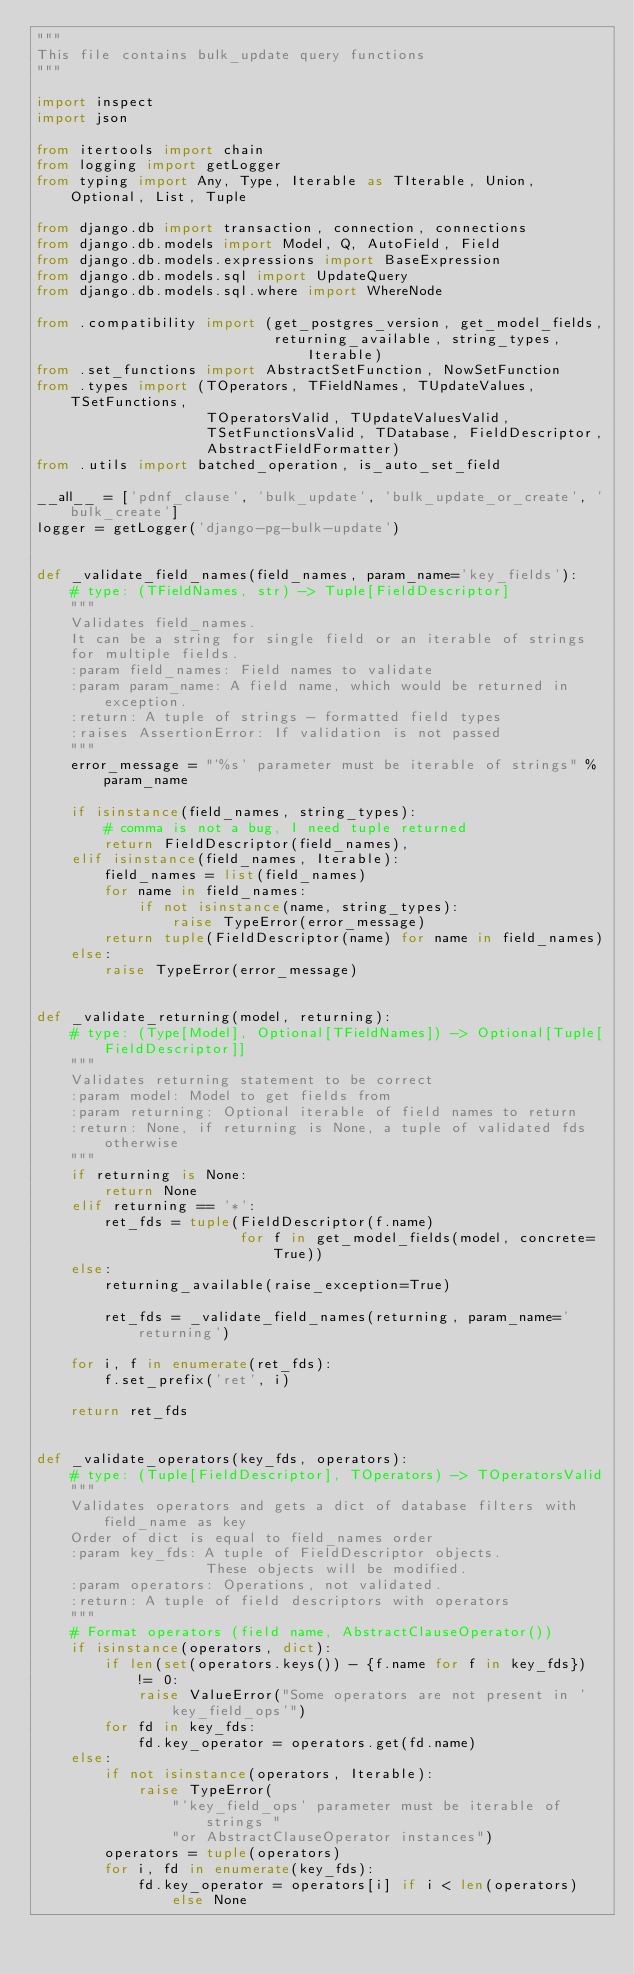Convert code to text. <code><loc_0><loc_0><loc_500><loc_500><_Python_>"""
This file contains bulk_update query functions
"""

import inspect
import json

from itertools import chain
from logging import getLogger
from typing import Any, Type, Iterable as TIterable, Union, Optional, List, Tuple

from django.db import transaction, connection, connections
from django.db.models import Model, Q, AutoField, Field
from django.db.models.expressions import BaseExpression
from django.db.models.sql import UpdateQuery
from django.db.models.sql.where import WhereNode

from .compatibility import (get_postgres_version, get_model_fields,
                            returning_available, string_types, Iterable)
from .set_functions import AbstractSetFunction, NowSetFunction
from .types import (TOperators, TFieldNames, TUpdateValues, TSetFunctions,
                    TOperatorsValid, TUpdateValuesValid,
                    TSetFunctionsValid, TDatabase, FieldDescriptor,
                    AbstractFieldFormatter)
from .utils import batched_operation, is_auto_set_field

__all__ = ['pdnf_clause', 'bulk_update', 'bulk_update_or_create', 'bulk_create']
logger = getLogger('django-pg-bulk-update')


def _validate_field_names(field_names, param_name='key_fields'):
    # type: (TFieldNames, str) -> Tuple[FieldDescriptor]
    """
    Validates field_names.
    It can be a string for single field or an iterable of strings
    for multiple fields.
    :param field_names: Field names to validate
    :param param_name: A field name, which would be returned in exception.
    :return: A tuple of strings - formatted field types
    :raises AssertionError: If validation is not passed
    """
    error_message = "'%s' parameter must be iterable of strings" % param_name

    if isinstance(field_names, string_types):
        # comma is not a bug, I need tuple returned
        return FieldDescriptor(field_names),
    elif isinstance(field_names, Iterable):
        field_names = list(field_names)
        for name in field_names:
            if not isinstance(name, string_types):
                raise TypeError(error_message)
        return tuple(FieldDescriptor(name) for name in field_names)
    else:
        raise TypeError(error_message)


def _validate_returning(model, returning):
    # type: (Type[Model], Optional[TFieldNames]) -> Optional[Tuple[FieldDescriptor]]
    """
    Validates returning statement to be correct
    :param model: Model to get fields from
    :param returning: Optional iterable of field names to return
    :return: None, if returning is None, a tuple of validated fds otherwise
    """
    if returning is None:
        return None
    elif returning == '*':
        ret_fds = tuple(FieldDescriptor(f.name)
                        for f in get_model_fields(model, concrete=True))
    else:
        returning_available(raise_exception=True)

        ret_fds = _validate_field_names(returning, param_name='returning')

    for i, f in enumerate(ret_fds):
        f.set_prefix('ret', i)

    return ret_fds


def _validate_operators(key_fds, operators):
    # type: (Tuple[FieldDescriptor], TOperators) -> TOperatorsValid
    """
    Validates operators and gets a dict of database filters with field_name as key
    Order of dict is equal to field_names order
    :param key_fds: A tuple of FieldDescriptor objects.
                    These objects will be modified.
    :param operators: Operations, not validated.
    :return: A tuple of field descriptors with operators
    """
    # Format operators (field name, AbstractClauseOperator())
    if isinstance(operators, dict):
        if len(set(operators.keys()) - {f.name for f in key_fds}) != 0:
            raise ValueError("Some operators are not present in 'key_field_ops'")
        for fd in key_fds:
            fd.key_operator = operators.get(fd.name)
    else:
        if not isinstance(operators, Iterable):
            raise TypeError(
                "'key_field_ops' parameter must be iterable of strings "
                "or AbstractClauseOperator instances")
        operators = tuple(operators)
        for i, fd in enumerate(key_fds):
            fd.key_operator = operators[i] if i < len(operators) else None
</code> 